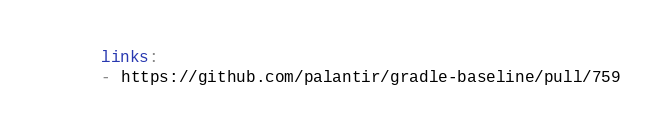Convert code to text. <code><loc_0><loc_0><loc_500><loc_500><_YAML_>  links:
  - https://github.com/palantir/gradle-baseline/pull/759
</code> 